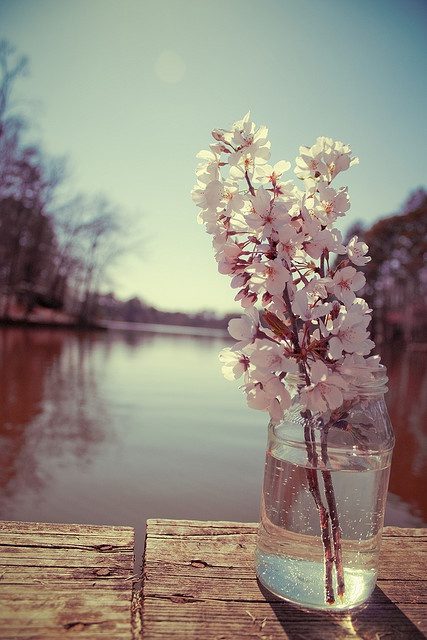Describe the objects in this image and their specific colors. I can see a vase in teal, brown, gray, and darkgray tones in this image. 